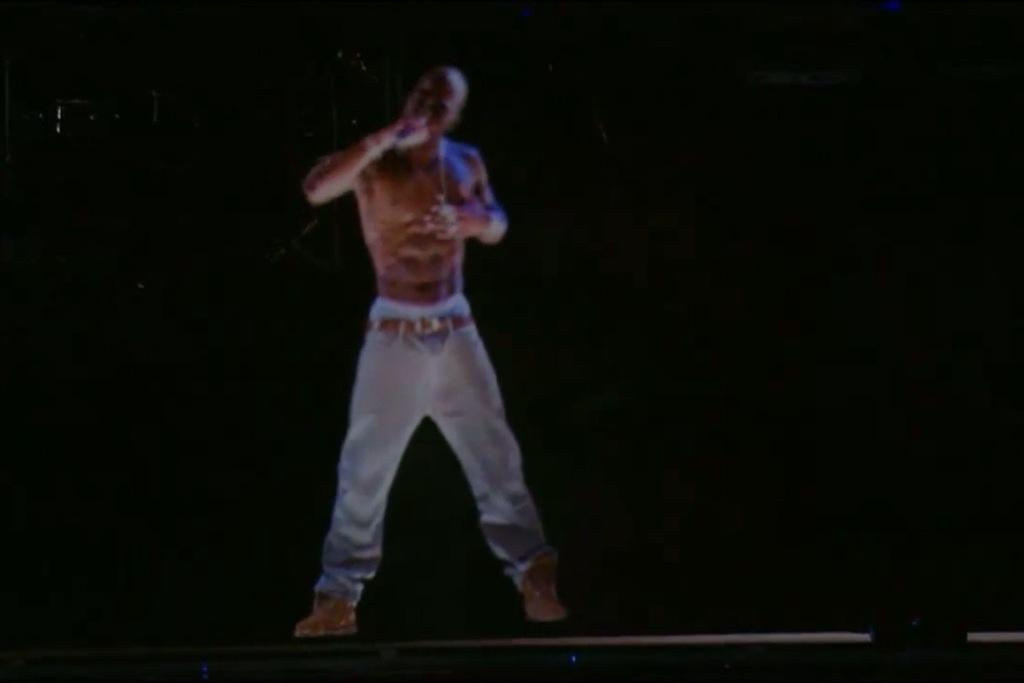What is the main subject of the image? The main subject of the image is a man standing. What can be observed about the background of the image? The background of the image is dark. Can you see the man jumping with a bird in the wilderness in the image? There is no indication of the man jumping or a bird being present in the image. The image only shows a man standing in a dark background. 